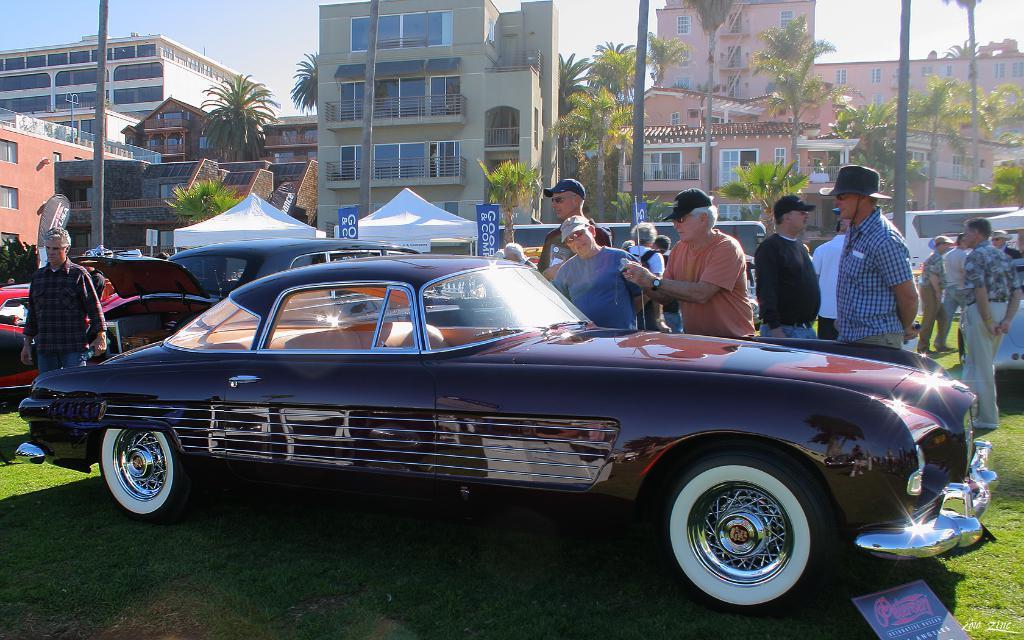Please provide a concise description of this image. In this image there are a group of people some cars, tents, boards and at the bottom there is grass. And in the background there are some buildings, trees, poles, railing and at the top there is sky. 